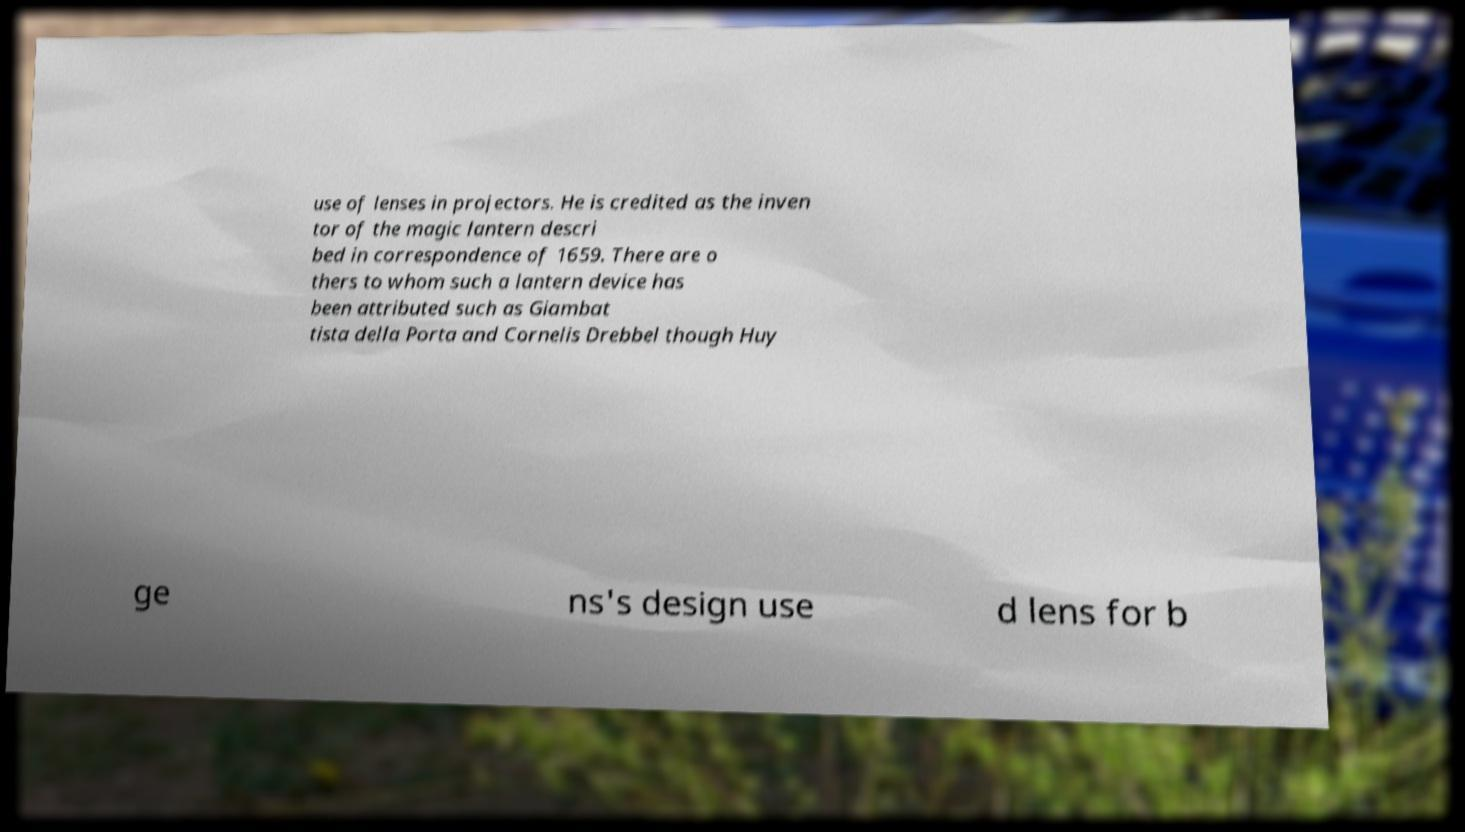Could you assist in decoding the text presented in this image and type it out clearly? use of lenses in projectors. He is credited as the inven tor of the magic lantern descri bed in correspondence of 1659. There are o thers to whom such a lantern device has been attributed such as Giambat tista della Porta and Cornelis Drebbel though Huy ge ns's design use d lens for b 